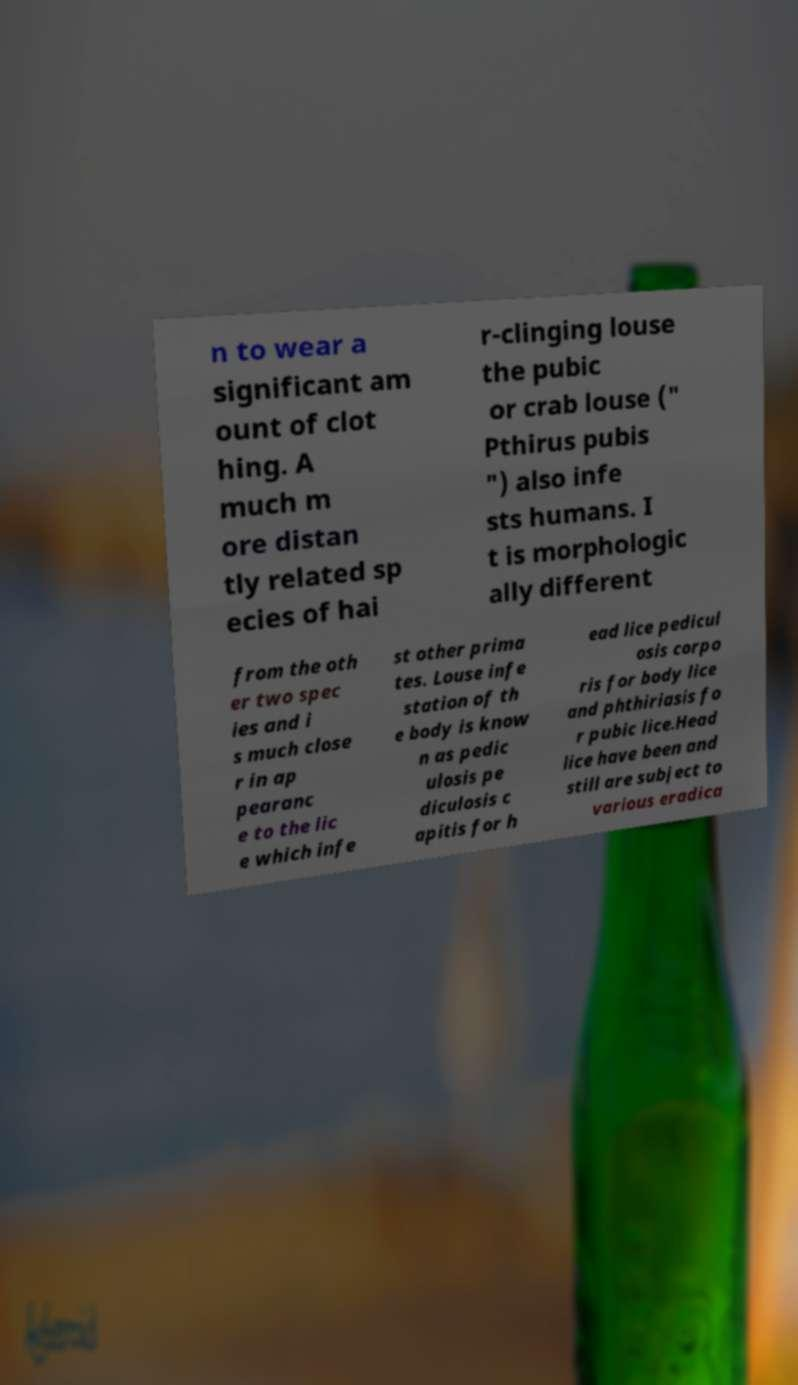What messages or text are displayed in this image? I need them in a readable, typed format. n to wear a significant am ount of clot hing. A much m ore distan tly related sp ecies of hai r-clinging louse the pubic or crab louse (" Pthirus pubis ") also infe sts humans. I t is morphologic ally different from the oth er two spec ies and i s much close r in ap pearanc e to the lic e which infe st other prima tes. Louse infe station of th e body is know n as pedic ulosis pe diculosis c apitis for h ead lice pedicul osis corpo ris for body lice and phthiriasis fo r pubic lice.Head lice have been and still are subject to various eradica 